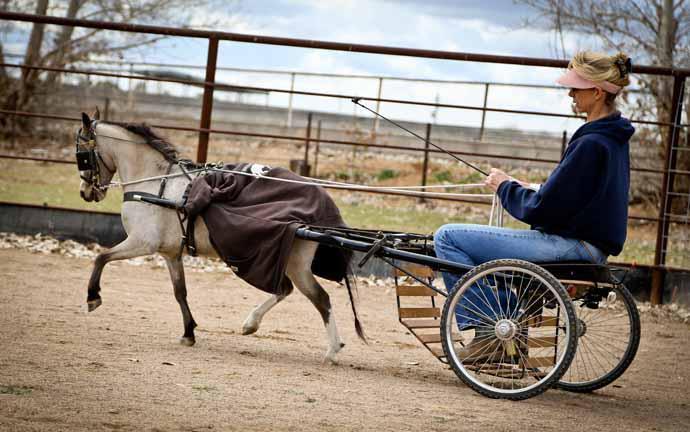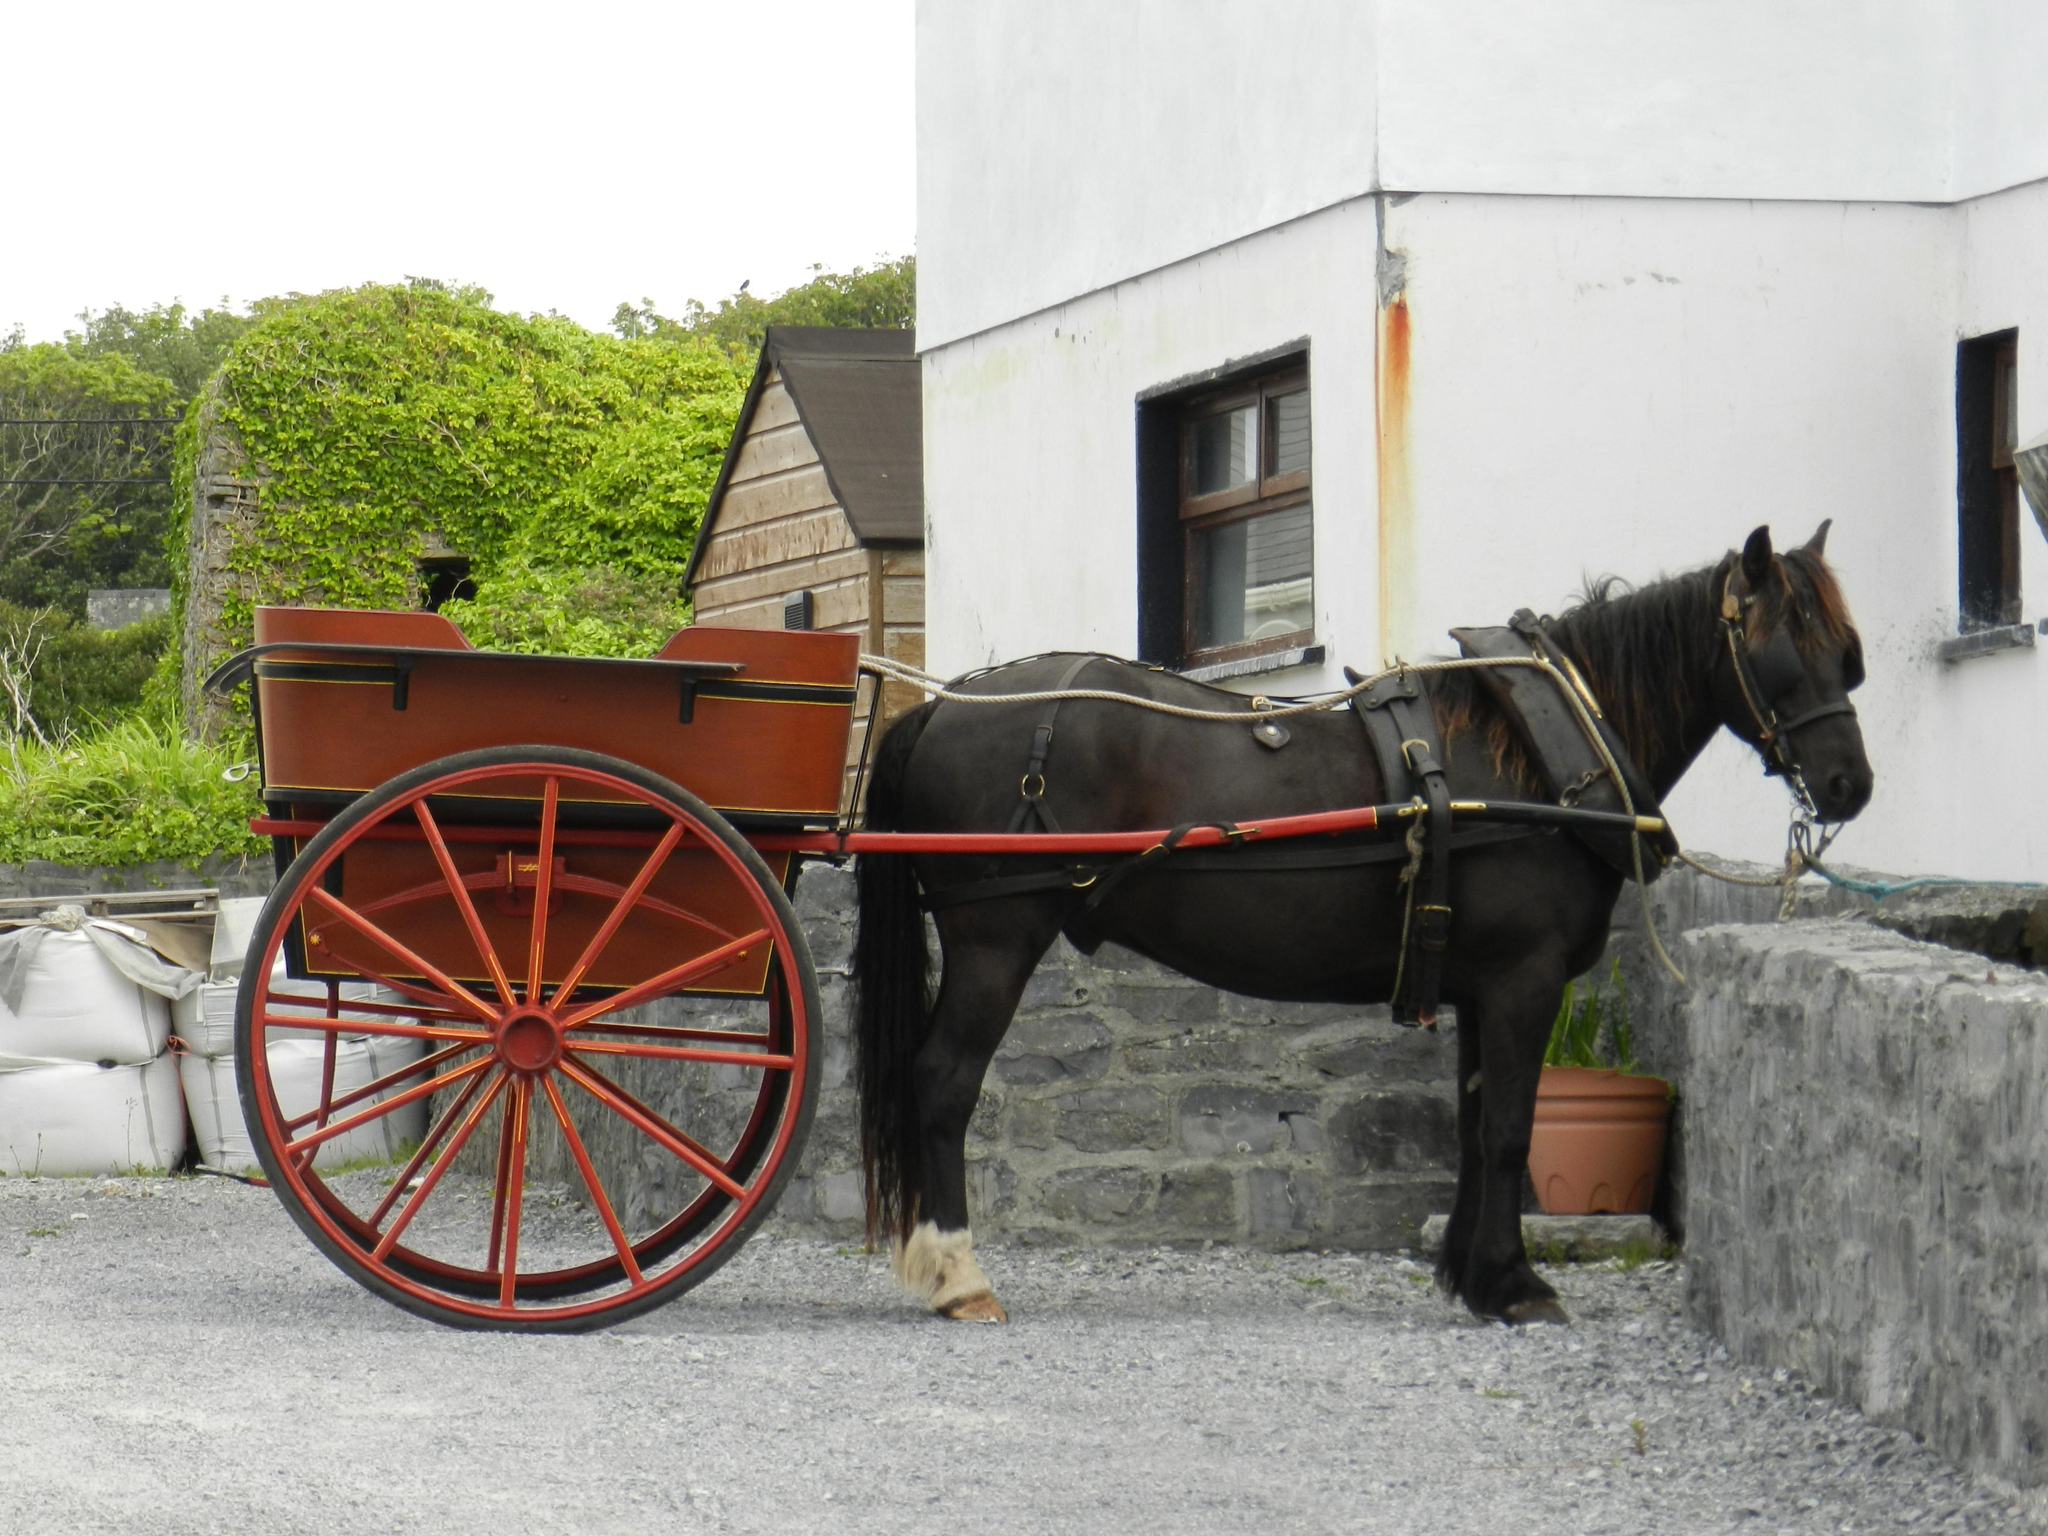The first image is the image on the left, the second image is the image on the right. For the images displayed, is the sentence "there is a black horse in the image on the right" factually correct? Answer yes or no. Yes. The first image is the image on the left, the second image is the image on the right. Evaluate the accuracy of this statement regarding the images: "One image shows an empty cart parked in front of a garage door.". Is it true? Answer yes or no. No. 